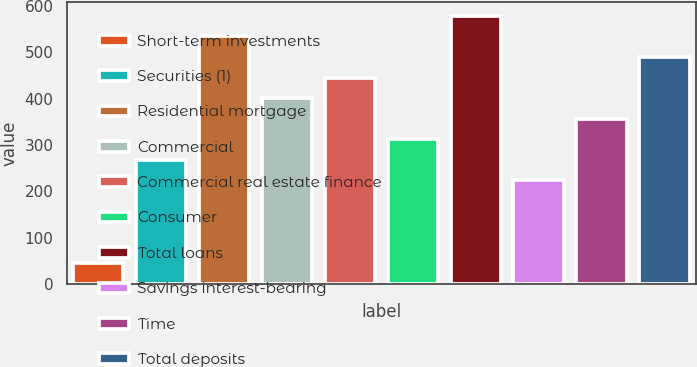Convert chart. <chart><loc_0><loc_0><loc_500><loc_500><bar_chart><fcel>Short-term investments<fcel>Securities (1)<fcel>Residential mortgage<fcel>Commercial<fcel>Commercial real estate finance<fcel>Consumer<fcel>Total loans<fcel>Savings interest-bearing<fcel>Time<fcel>Total deposits<nl><fcel>45.8<fcel>267.8<fcel>534.2<fcel>401<fcel>445.4<fcel>312.2<fcel>578.6<fcel>223.4<fcel>356.6<fcel>489.8<nl></chart> 